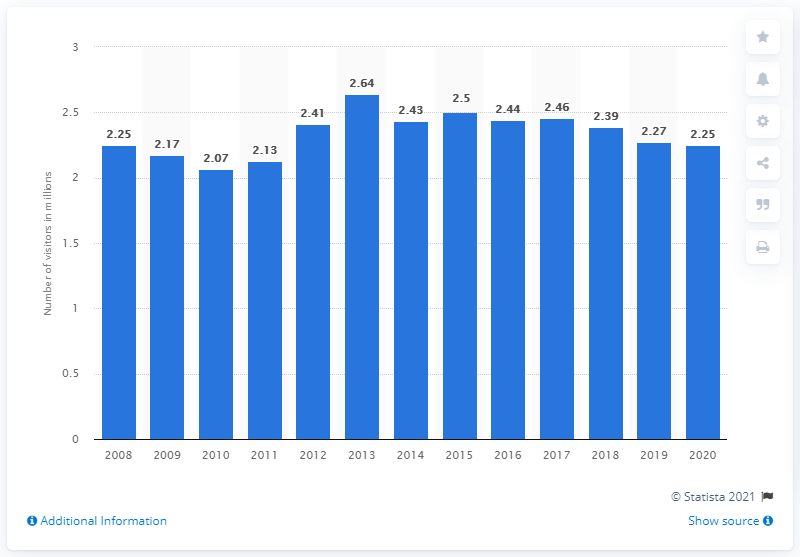List a handful of essential elements in this visual. In 2020, there were 2.25 million visitors to Point Reyes National Seashore. 